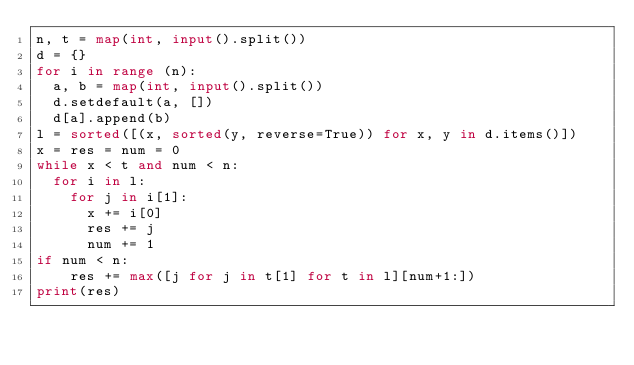Convert code to text. <code><loc_0><loc_0><loc_500><loc_500><_Python_>n, t = map(int, input().split())
d = {}
for i in range (n):
  a, b = map(int, input().split())
  d.setdefault(a, [])
  d[a].append(b)
l = sorted([(x, sorted(y, reverse=True)) for x, y in d.items()])
x = res = num = 0
while x < t and num < n:
  for i in l:
    for j in i[1]:
      x += i[0]
      res += j
      num += 1
if num < n:
	res += max([j for j in t[1] for t in l][num+1:])
print(res)</code> 